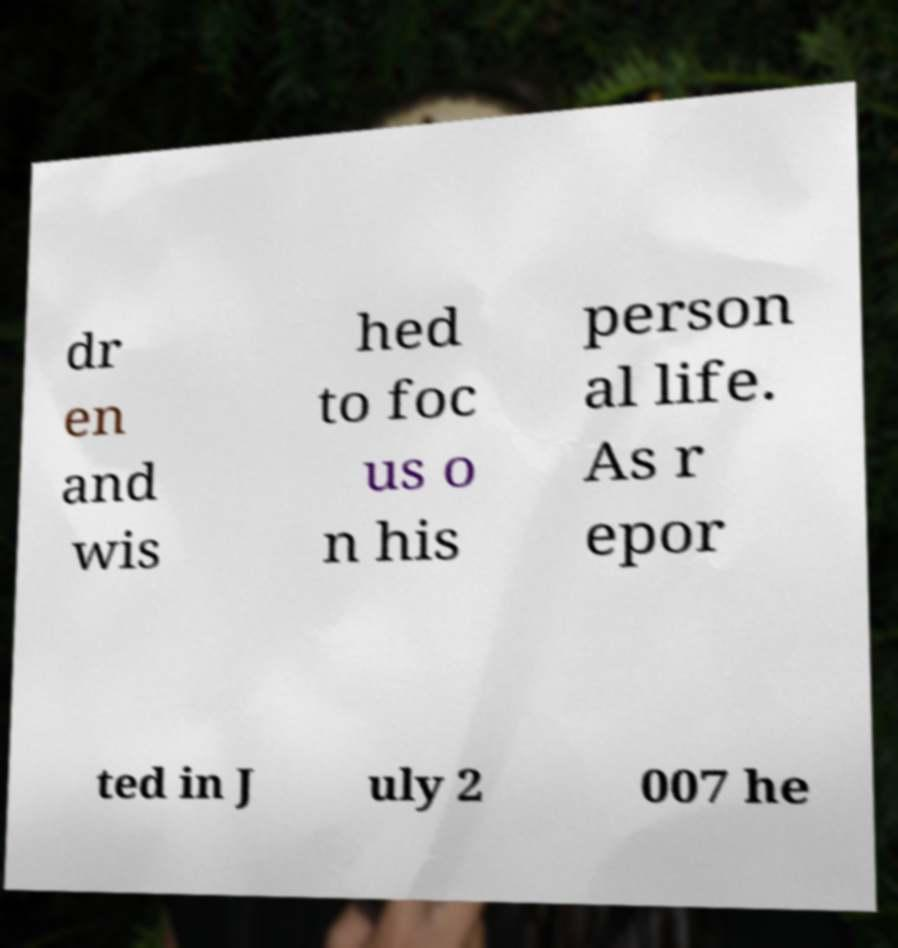There's text embedded in this image that I need extracted. Can you transcribe it verbatim? dr en and wis hed to foc us o n his person al life. As r epor ted in J uly 2 007 he 